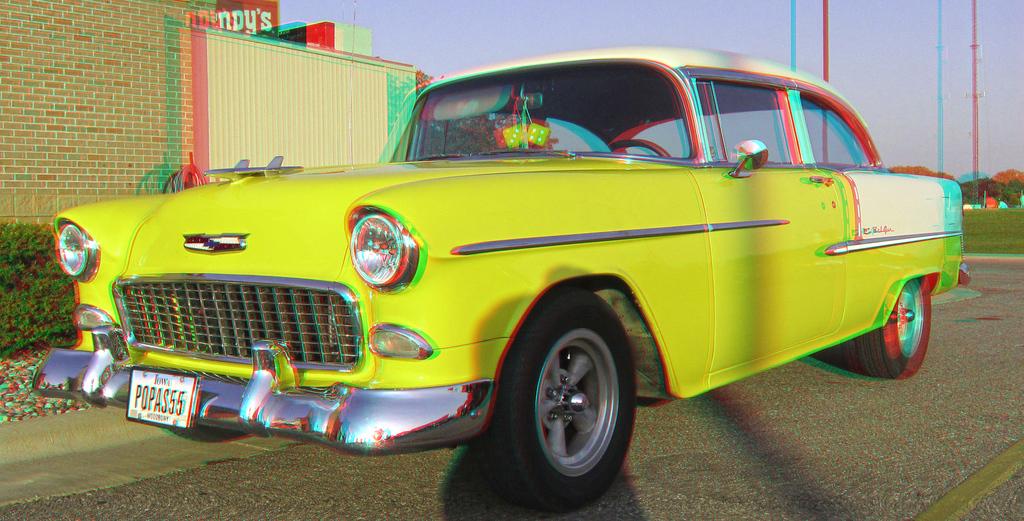What is the license plate number?
Ensure brevity in your answer.  Popas55. What state are they from?
Your answer should be compact. Iowa. 